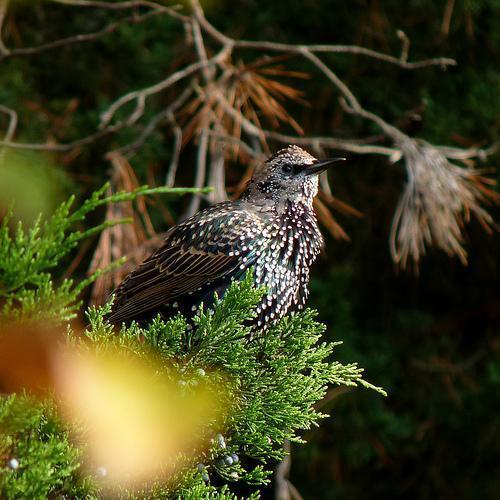How many birds are there?
Give a very brief answer. 1. 